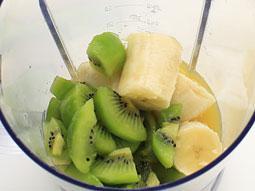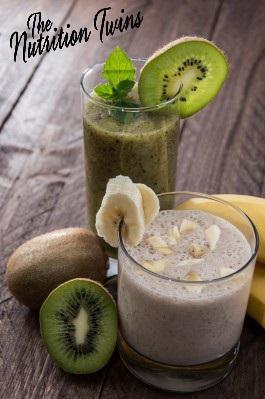The first image is the image on the left, the second image is the image on the right. Assess this claim about the two images: "One image shows chopped kiwi fruit, banana chunks, and lemon juice, while the second image includes a prepared green smoothie and cut kiwi fruit.". Correct or not? Answer yes or no. Yes. 